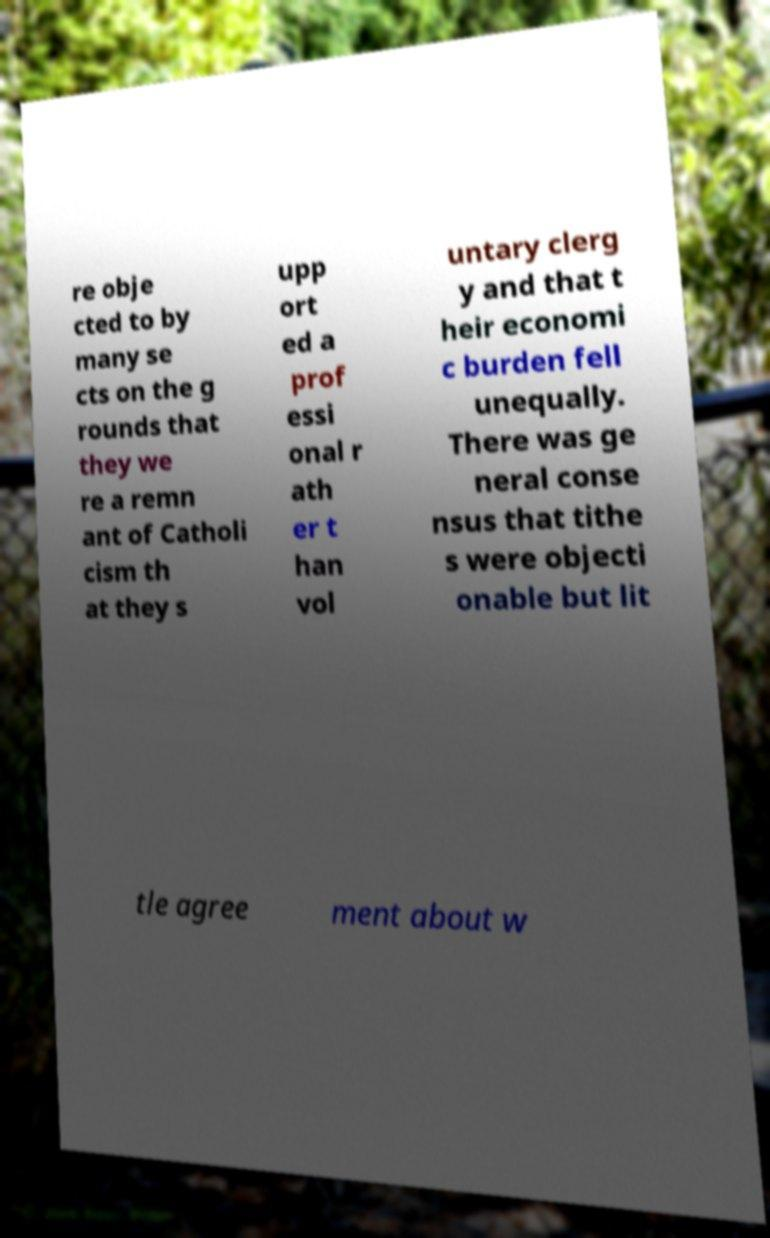Can you read and provide the text displayed in the image?This photo seems to have some interesting text. Can you extract and type it out for me? re obje cted to by many se cts on the g rounds that they we re a remn ant of Catholi cism th at they s upp ort ed a prof essi onal r ath er t han vol untary clerg y and that t heir economi c burden fell unequally. There was ge neral conse nsus that tithe s were objecti onable but lit tle agree ment about w 